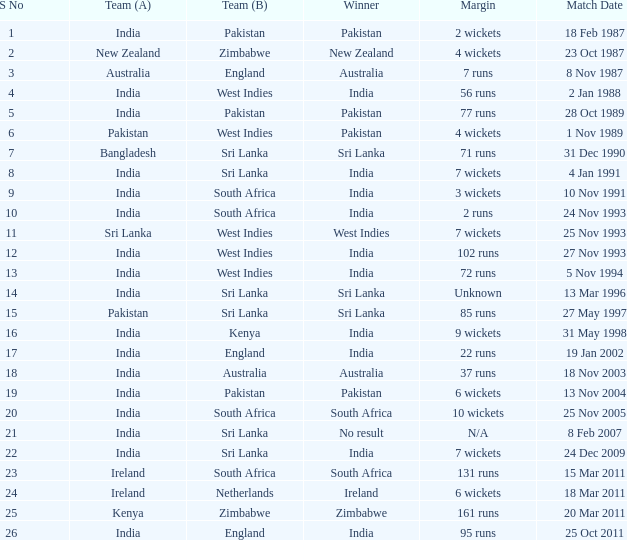What day did the west indies achieve the match win? 25 Nov 1993. 